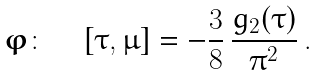Convert formula to latex. <formula><loc_0><loc_0><loc_500><loc_500>\boldsymbol \varphi \colon \quad \left [ \tau , \mu \right ] = - \frac { 3 } { 8 } \, \frac { g _ { 2 } ( \tau ) } { \pi ^ { 2 } } \, .</formula> 